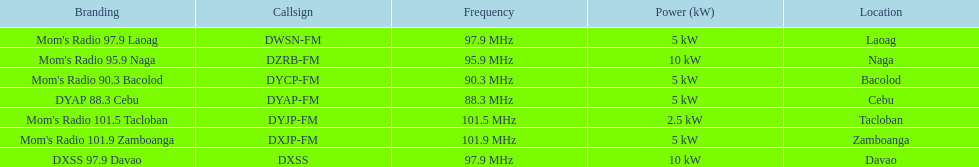How many stations transmit at a 5kw power level? 4. 